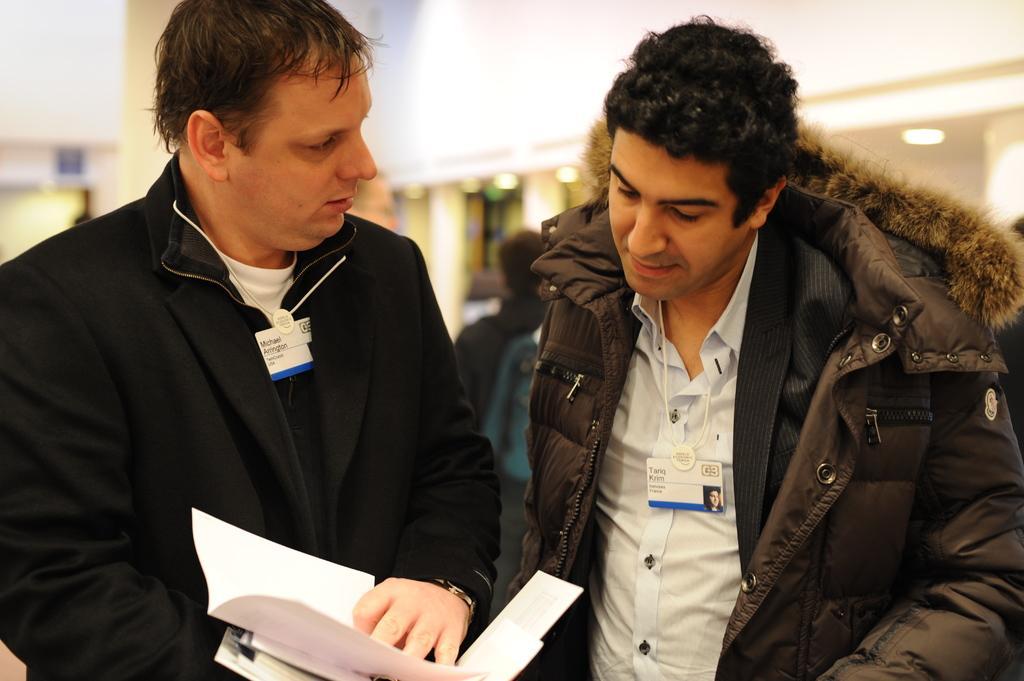How would you summarize this image in a sentence or two? 2 people are standing. The person at the left is holding papers. They are wearing id cards. The background is blurred. 